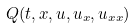<formula> <loc_0><loc_0><loc_500><loc_500>Q ( t , x , u , u _ { x } , u _ { x x } )</formula> 